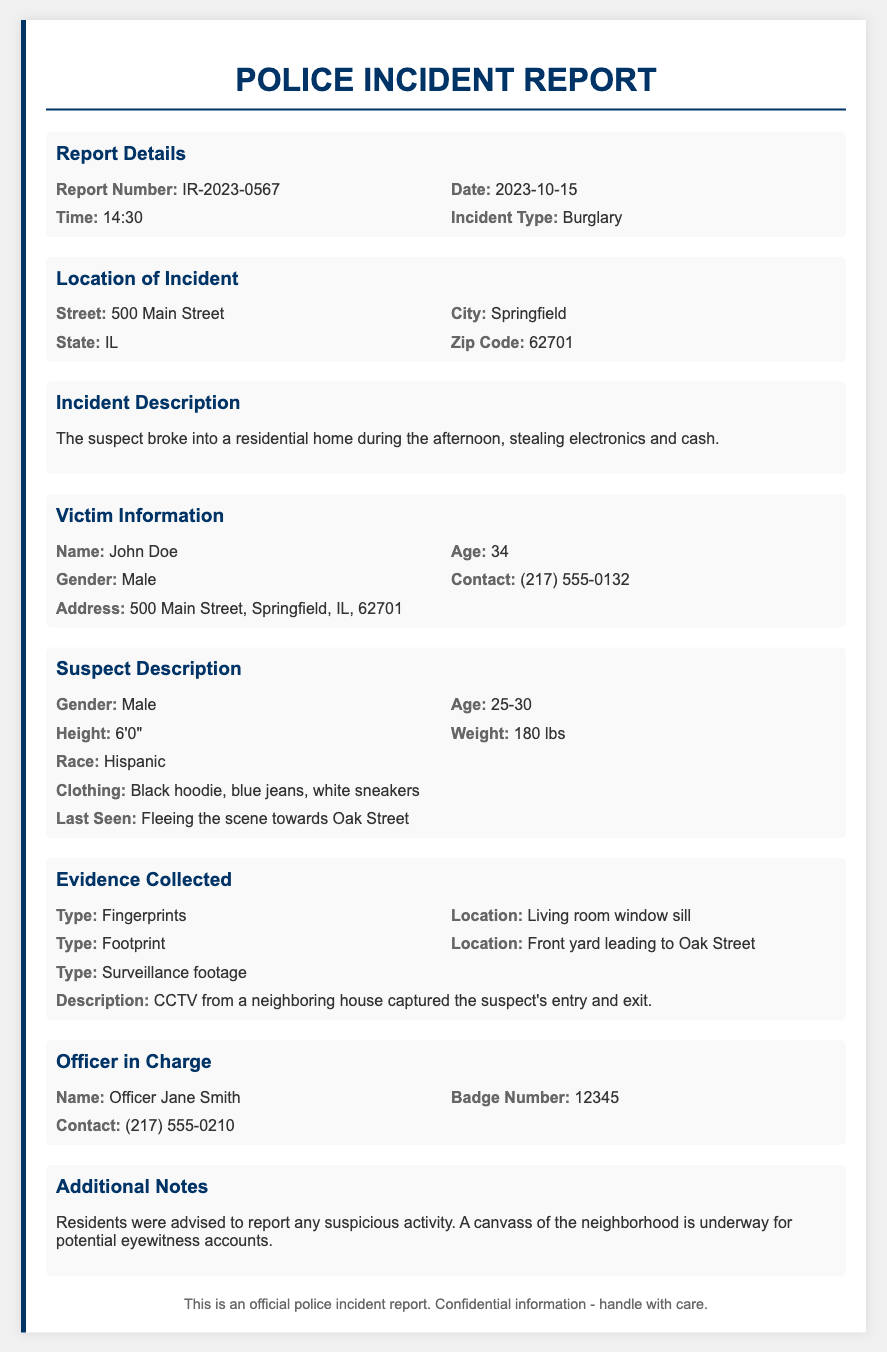what is the report number? The report number is specified in the report details section, which is IR-2023-0567.
Answer: IR-2023-0567 what is the date of the incident? The date is provided in the report details section, which is 2023-10-15.
Answer: 2023-10-15 who is the victim? The victim's name is mentioned in the victim information section, which is John Doe.
Answer: John Doe what type of incident occurred? The incident type is listed in the report details section, which is Burglary.
Answer: Burglary what clothing did the suspect wear? The suspect's clothing description is found in the suspect description section, mentioning a black hoodie, blue jeans, and white sneakers.
Answer: Black hoodie, blue jeans, white sneakers how was the evidence collected? Evidence collection description requires reasoning across sections; the report specifies types and locations in the evidence collected section: fingerprints, footprint, and surveillance footage.
Answer: Fingerprints, footprint, surveillance footage what actions were advised to residents? The additional notes section provides details on actions to be taken, advising residents to report suspicious activity.
Answer: Report suspicious activity who is the officer in charge? The officer in charge's name is found in the officer section, which is Officer Jane Smith.
Answer: Officer Jane Smith 